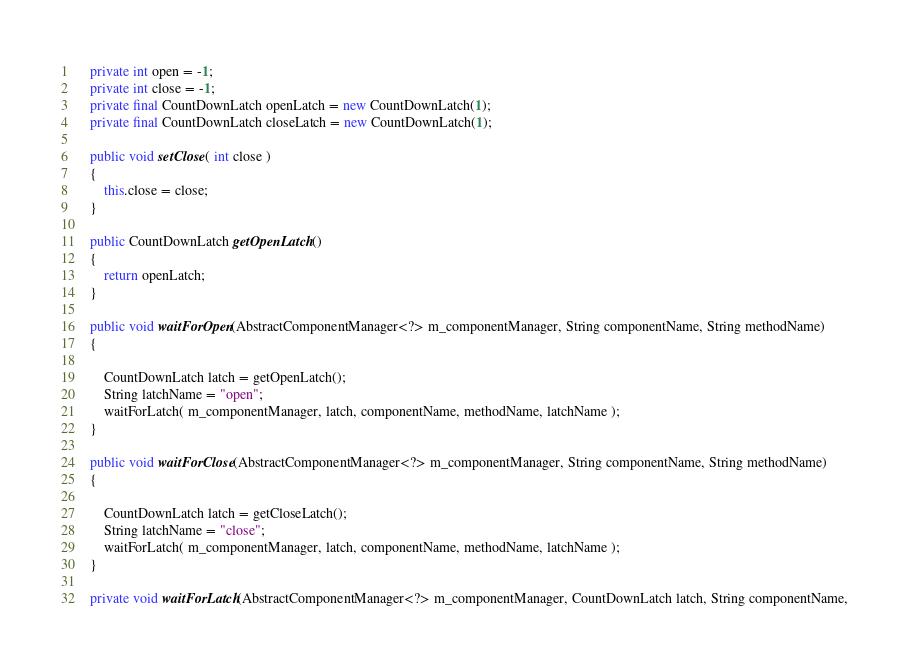<code> <loc_0><loc_0><loc_500><loc_500><_Java_>    private int open = -1;
    private int close = -1;
    private final CountDownLatch openLatch = new CountDownLatch(1);
    private final CountDownLatch closeLatch = new CountDownLatch(1);

    public void setClose( int close )
    {
        this.close = close;
    }

    public CountDownLatch getOpenLatch()
    {
        return openLatch;
    }

    public void waitForOpen(AbstractComponentManager<?> m_componentManager, String componentName, String methodName)
    {

        CountDownLatch latch = getOpenLatch();
        String latchName = "open";
        waitForLatch( m_componentManager, latch, componentName, methodName, latchName );
    }

    public void waitForClose(AbstractComponentManager<?> m_componentManager, String componentName, String methodName)
    {

        CountDownLatch latch = getCloseLatch();
        String latchName = "close";
        waitForLatch( m_componentManager, latch, componentName, methodName, latchName );
    }

    private void waitForLatch(AbstractComponentManager<?> m_componentManager, CountDownLatch latch, String componentName,</code> 